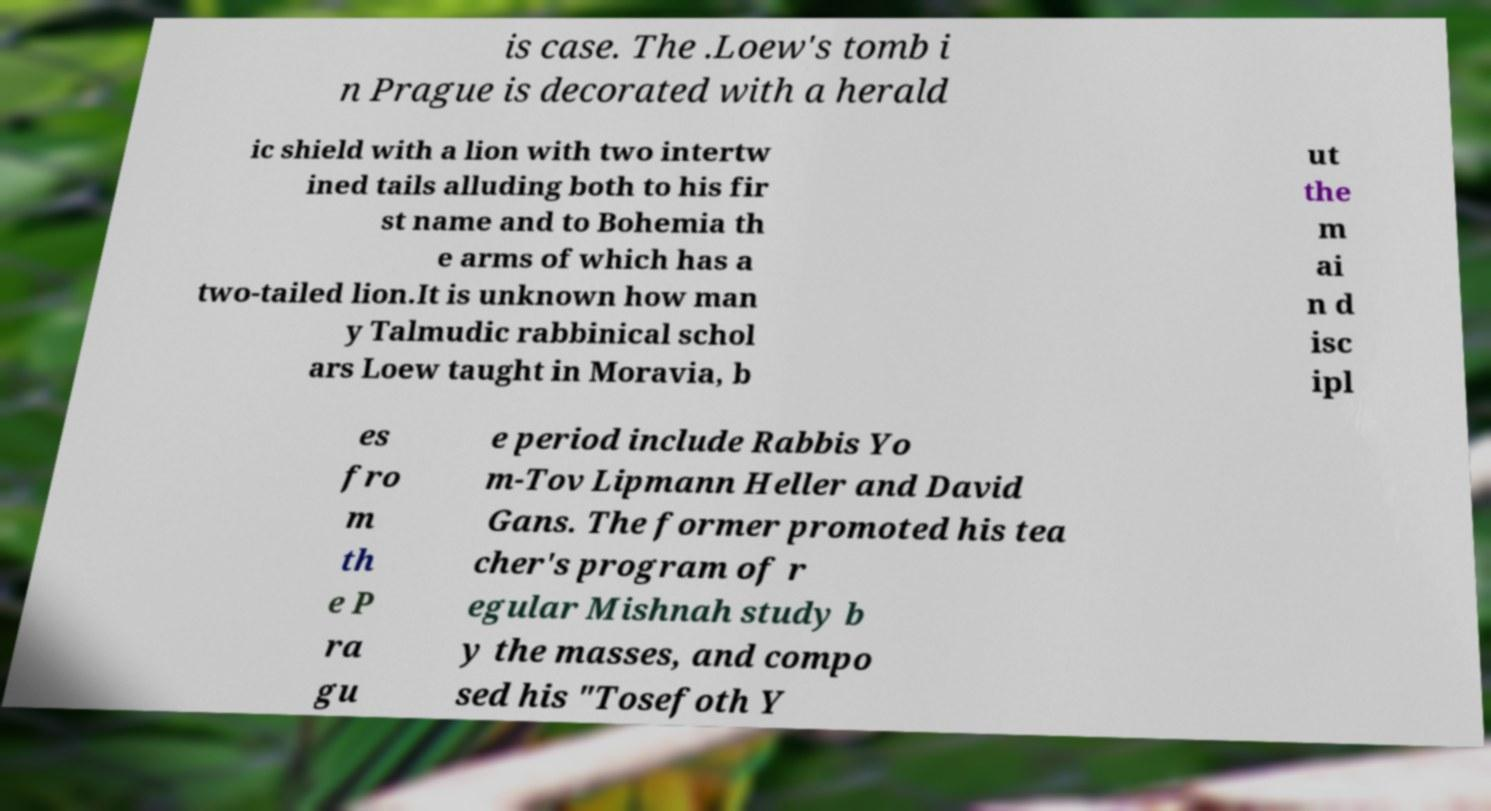Can you read and provide the text displayed in the image?This photo seems to have some interesting text. Can you extract and type it out for me? is case. The .Loew's tomb i n Prague is decorated with a herald ic shield with a lion with two intertw ined tails alluding both to his fir st name and to Bohemia th e arms of which has a two-tailed lion.It is unknown how man y Talmudic rabbinical schol ars Loew taught in Moravia, b ut the m ai n d isc ipl es fro m th e P ra gu e period include Rabbis Yo m-Tov Lipmann Heller and David Gans. The former promoted his tea cher's program of r egular Mishnah study b y the masses, and compo sed his "Tosefoth Y 